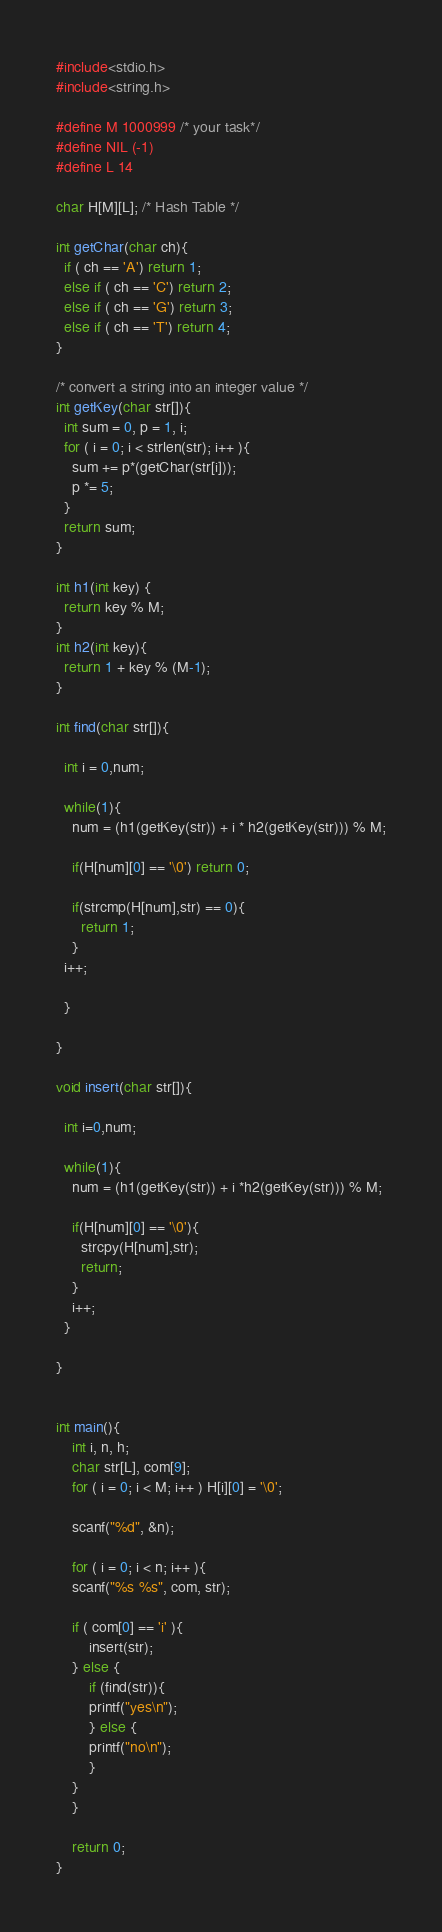<code> <loc_0><loc_0><loc_500><loc_500><_C_>#include<stdio.h>
#include<string.h>

#define M 1000999 /* your task*/
#define NIL (-1)
#define L 14

char H[M][L]; /* Hash Table */

int getChar(char ch){
  if ( ch == 'A') return 1;
  else if ( ch == 'C') return 2;
  else if ( ch == 'G') return 3;
  else if ( ch == 'T') return 4;
}

/* convert a string into an integer value */
int getKey(char str[]){
  int sum = 0, p = 1, i;
  for ( i = 0; i < strlen(str); i++ ){
    sum += p*(getChar(str[i]));
    p *= 5;
  }
  return sum;
}

int h1(int key) {
  return key % M;
}
int h2(int key){
  return 1 + key % (M-1);
}

int find(char str[]){

  int i = 0,num;

  while(1){
    num = (h1(getKey(str)) + i * h2(getKey(str))) % M;

    if(H[num][0] == '\0') return 0;    

    if(strcmp(H[num],str) == 0){
      return 1;
    }
  i++;

  }

}

void insert(char str[]){

  int i=0,num;

  while(1){
    num = (h1(getKey(str)) + i *h2(getKey(str))) % M;
    
    if(H[num][0] == '\0'){  
      strcpy(H[num],str);
      return;
    } 
    i++;
  }
  
}


int main(){
    int i, n, h;
    char str[L], com[9];
    for ( i = 0; i < M; i++ ) H[i][0] = '\0';
    
    scanf("%d", &n);
    
    for ( i = 0; i < n; i++ ){
	scanf("%s %s", com, str);
	
	if ( com[0] == 'i' ){
	    insert(str);
	} else {
	    if (find(str)){
		printf("yes\n");
	    } else {
		printf("no\n");
	    }
	}
    }

    return 0;
}</code> 